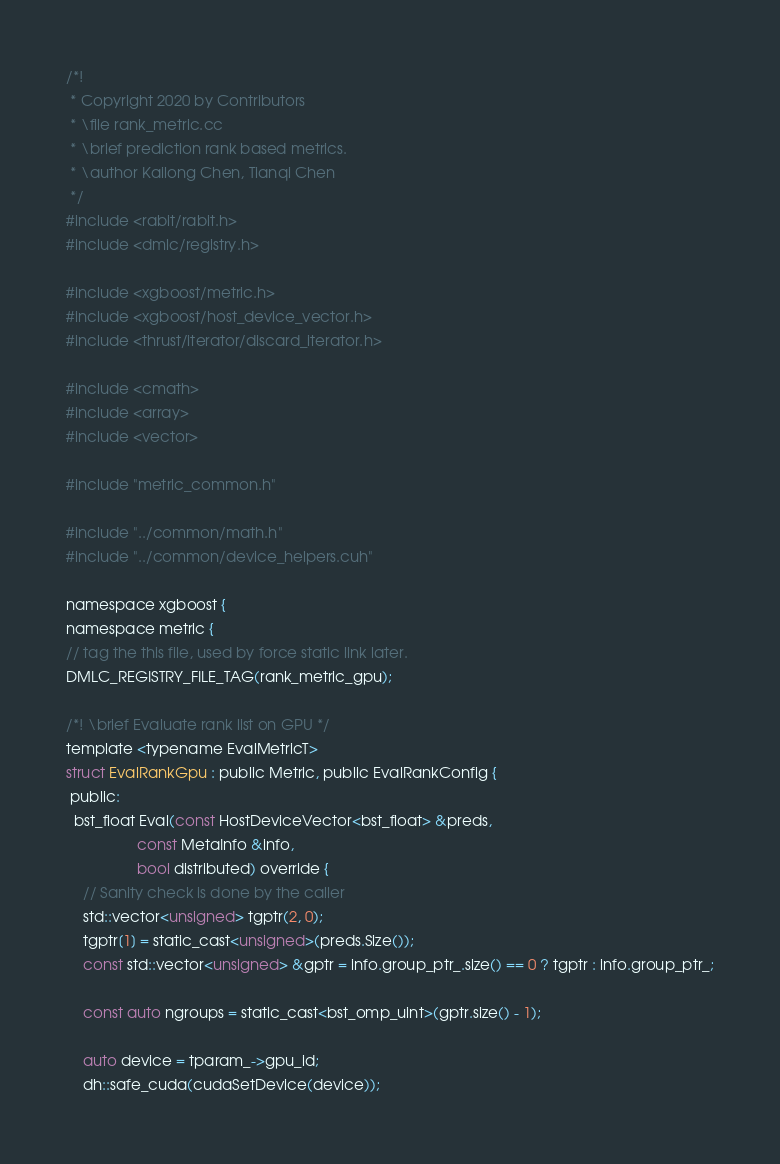Convert code to text. <code><loc_0><loc_0><loc_500><loc_500><_Cuda_>/*!
 * Copyright 2020 by Contributors
 * \file rank_metric.cc
 * \brief prediction rank based metrics.
 * \author Kailong Chen, Tianqi Chen
 */
#include <rabit/rabit.h>
#include <dmlc/registry.h>

#include <xgboost/metric.h>
#include <xgboost/host_device_vector.h>
#include <thrust/iterator/discard_iterator.h>

#include <cmath>
#include <array>
#include <vector>

#include "metric_common.h"

#include "../common/math.h"
#include "../common/device_helpers.cuh"

namespace xgboost {
namespace metric {
// tag the this file, used by force static link later.
DMLC_REGISTRY_FILE_TAG(rank_metric_gpu);

/*! \brief Evaluate rank list on GPU */
template <typename EvalMetricT>
struct EvalRankGpu : public Metric, public EvalRankConfig {
 public:
  bst_float Eval(const HostDeviceVector<bst_float> &preds,
                 const MetaInfo &info,
                 bool distributed) override {
    // Sanity check is done by the caller
    std::vector<unsigned> tgptr(2, 0);
    tgptr[1] = static_cast<unsigned>(preds.Size());
    const std::vector<unsigned> &gptr = info.group_ptr_.size() == 0 ? tgptr : info.group_ptr_;

    const auto ngroups = static_cast<bst_omp_uint>(gptr.size() - 1);

    auto device = tparam_->gpu_id;
    dh::safe_cuda(cudaSetDevice(device));
</code> 